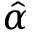<formula> <loc_0><loc_0><loc_500><loc_500>\hat { \alpha }</formula> 